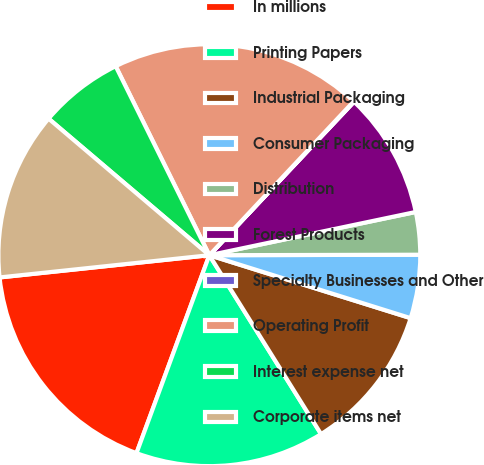Convert chart. <chart><loc_0><loc_0><loc_500><loc_500><pie_chart><fcel>In millions<fcel>Printing Papers<fcel>Industrial Packaging<fcel>Consumer Packaging<fcel>Distribution<fcel>Forest Products<fcel>Specialty Businesses and Other<fcel>Operating Profit<fcel>Interest expense net<fcel>Corporate items net<nl><fcel>17.71%<fcel>14.5%<fcel>11.29%<fcel>4.86%<fcel>3.25%<fcel>9.68%<fcel>0.04%<fcel>19.32%<fcel>6.47%<fcel>12.89%<nl></chart> 